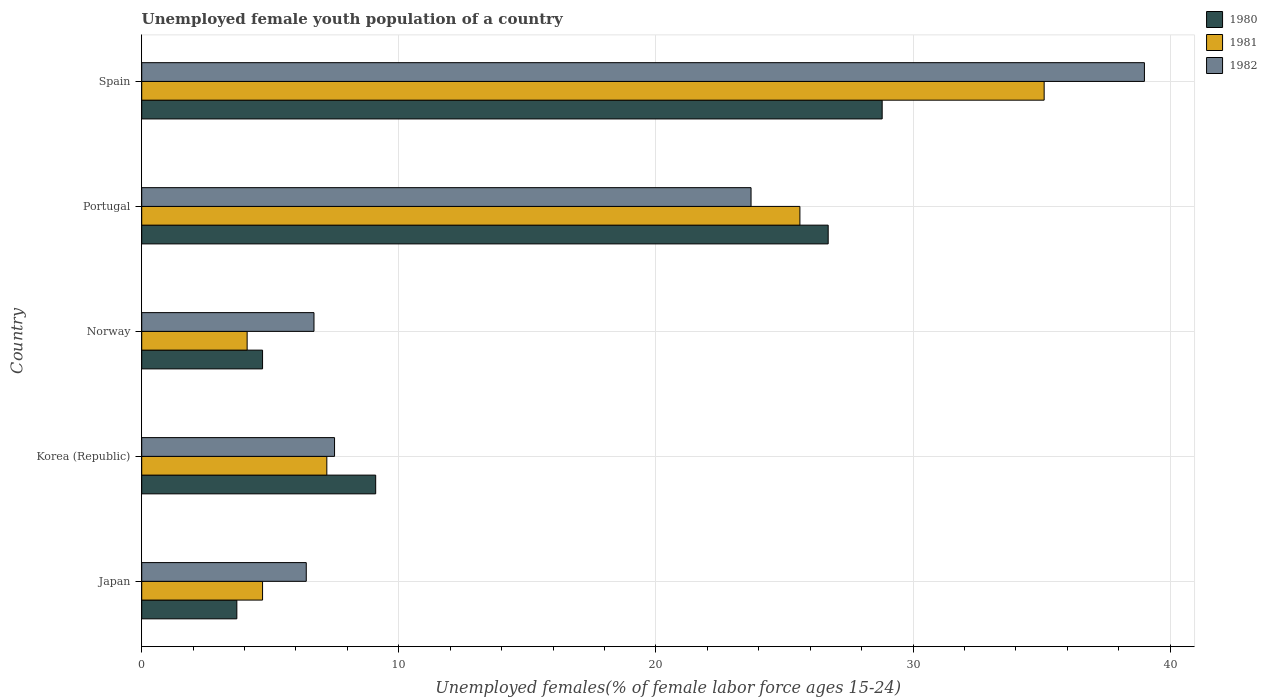How many different coloured bars are there?
Offer a terse response. 3. What is the percentage of unemployed female youth population in 1982 in Japan?
Provide a succinct answer. 6.4. Across all countries, what is the minimum percentage of unemployed female youth population in 1980?
Ensure brevity in your answer.  3.7. In which country was the percentage of unemployed female youth population in 1981 maximum?
Keep it short and to the point. Spain. In which country was the percentage of unemployed female youth population in 1981 minimum?
Offer a very short reply. Norway. What is the total percentage of unemployed female youth population in 1980 in the graph?
Offer a very short reply. 73. What is the difference between the percentage of unemployed female youth population in 1982 in Japan and that in Norway?
Offer a terse response. -0.3. What is the difference between the percentage of unemployed female youth population in 1980 in Korea (Republic) and the percentage of unemployed female youth population in 1982 in Portugal?
Ensure brevity in your answer.  -14.6. What is the average percentage of unemployed female youth population in 1980 per country?
Make the answer very short. 14.6. What is the difference between the percentage of unemployed female youth population in 1982 and percentage of unemployed female youth population in 1981 in Japan?
Provide a short and direct response. 1.7. What is the ratio of the percentage of unemployed female youth population in 1980 in Japan to that in Norway?
Your answer should be very brief. 0.79. Is the difference between the percentage of unemployed female youth population in 1982 in Norway and Portugal greater than the difference between the percentage of unemployed female youth population in 1981 in Norway and Portugal?
Your answer should be compact. Yes. What is the difference between the highest and the second highest percentage of unemployed female youth population in 1982?
Your answer should be very brief. 15.3. What is the difference between the highest and the lowest percentage of unemployed female youth population in 1982?
Your response must be concise. 32.6. What does the 2nd bar from the top in Japan represents?
Provide a succinct answer. 1981. Are all the bars in the graph horizontal?
Your response must be concise. Yes. What is the difference between two consecutive major ticks on the X-axis?
Offer a very short reply. 10. Are the values on the major ticks of X-axis written in scientific E-notation?
Provide a short and direct response. No. Where does the legend appear in the graph?
Provide a succinct answer. Top right. How are the legend labels stacked?
Provide a succinct answer. Vertical. What is the title of the graph?
Your answer should be very brief. Unemployed female youth population of a country. Does "2000" appear as one of the legend labels in the graph?
Provide a succinct answer. No. What is the label or title of the X-axis?
Make the answer very short. Unemployed females(% of female labor force ages 15-24). What is the label or title of the Y-axis?
Your answer should be compact. Country. What is the Unemployed females(% of female labor force ages 15-24) in 1980 in Japan?
Give a very brief answer. 3.7. What is the Unemployed females(% of female labor force ages 15-24) of 1981 in Japan?
Offer a terse response. 4.7. What is the Unemployed females(% of female labor force ages 15-24) of 1982 in Japan?
Offer a terse response. 6.4. What is the Unemployed females(% of female labor force ages 15-24) of 1980 in Korea (Republic)?
Give a very brief answer. 9.1. What is the Unemployed females(% of female labor force ages 15-24) in 1981 in Korea (Republic)?
Give a very brief answer. 7.2. What is the Unemployed females(% of female labor force ages 15-24) of 1980 in Norway?
Keep it short and to the point. 4.7. What is the Unemployed females(% of female labor force ages 15-24) of 1981 in Norway?
Ensure brevity in your answer.  4.1. What is the Unemployed females(% of female labor force ages 15-24) of 1982 in Norway?
Offer a very short reply. 6.7. What is the Unemployed females(% of female labor force ages 15-24) in 1980 in Portugal?
Ensure brevity in your answer.  26.7. What is the Unemployed females(% of female labor force ages 15-24) in 1981 in Portugal?
Give a very brief answer. 25.6. What is the Unemployed females(% of female labor force ages 15-24) of 1982 in Portugal?
Make the answer very short. 23.7. What is the Unemployed females(% of female labor force ages 15-24) in 1980 in Spain?
Keep it short and to the point. 28.8. What is the Unemployed females(% of female labor force ages 15-24) of 1981 in Spain?
Offer a terse response. 35.1. What is the Unemployed females(% of female labor force ages 15-24) of 1982 in Spain?
Provide a succinct answer. 39. Across all countries, what is the maximum Unemployed females(% of female labor force ages 15-24) of 1980?
Make the answer very short. 28.8. Across all countries, what is the maximum Unemployed females(% of female labor force ages 15-24) of 1981?
Offer a very short reply. 35.1. Across all countries, what is the maximum Unemployed females(% of female labor force ages 15-24) of 1982?
Ensure brevity in your answer.  39. Across all countries, what is the minimum Unemployed females(% of female labor force ages 15-24) in 1980?
Offer a very short reply. 3.7. Across all countries, what is the minimum Unemployed females(% of female labor force ages 15-24) in 1981?
Your answer should be compact. 4.1. Across all countries, what is the minimum Unemployed females(% of female labor force ages 15-24) in 1982?
Give a very brief answer. 6.4. What is the total Unemployed females(% of female labor force ages 15-24) in 1980 in the graph?
Your response must be concise. 73. What is the total Unemployed females(% of female labor force ages 15-24) of 1981 in the graph?
Give a very brief answer. 76.7. What is the total Unemployed females(% of female labor force ages 15-24) in 1982 in the graph?
Ensure brevity in your answer.  83.3. What is the difference between the Unemployed females(% of female labor force ages 15-24) in 1982 in Japan and that in Korea (Republic)?
Provide a short and direct response. -1.1. What is the difference between the Unemployed females(% of female labor force ages 15-24) in 1980 in Japan and that in Norway?
Provide a short and direct response. -1. What is the difference between the Unemployed females(% of female labor force ages 15-24) of 1980 in Japan and that in Portugal?
Your response must be concise. -23. What is the difference between the Unemployed females(% of female labor force ages 15-24) in 1981 in Japan and that in Portugal?
Your answer should be compact. -20.9. What is the difference between the Unemployed females(% of female labor force ages 15-24) in 1982 in Japan and that in Portugal?
Keep it short and to the point. -17.3. What is the difference between the Unemployed females(% of female labor force ages 15-24) of 1980 in Japan and that in Spain?
Keep it short and to the point. -25.1. What is the difference between the Unemployed females(% of female labor force ages 15-24) of 1981 in Japan and that in Spain?
Keep it short and to the point. -30.4. What is the difference between the Unemployed females(% of female labor force ages 15-24) of 1982 in Japan and that in Spain?
Provide a succinct answer. -32.6. What is the difference between the Unemployed females(% of female labor force ages 15-24) of 1982 in Korea (Republic) and that in Norway?
Offer a terse response. 0.8. What is the difference between the Unemployed females(% of female labor force ages 15-24) in 1980 in Korea (Republic) and that in Portugal?
Your response must be concise. -17.6. What is the difference between the Unemployed females(% of female labor force ages 15-24) in 1981 in Korea (Republic) and that in Portugal?
Ensure brevity in your answer.  -18.4. What is the difference between the Unemployed females(% of female labor force ages 15-24) in 1982 in Korea (Republic) and that in Portugal?
Provide a succinct answer. -16.2. What is the difference between the Unemployed females(% of female labor force ages 15-24) in 1980 in Korea (Republic) and that in Spain?
Offer a terse response. -19.7. What is the difference between the Unemployed females(% of female labor force ages 15-24) in 1981 in Korea (Republic) and that in Spain?
Offer a terse response. -27.9. What is the difference between the Unemployed females(% of female labor force ages 15-24) in 1982 in Korea (Republic) and that in Spain?
Offer a very short reply. -31.5. What is the difference between the Unemployed females(% of female labor force ages 15-24) in 1981 in Norway and that in Portugal?
Your response must be concise. -21.5. What is the difference between the Unemployed females(% of female labor force ages 15-24) of 1980 in Norway and that in Spain?
Make the answer very short. -24.1. What is the difference between the Unemployed females(% of female labor force ages 15-24) in 1981 in Norway and that in Spain?
Offer a terse response. -31. What is the difference between the Unemployed females(% of female labor force ages 15-24) of 1982 in Norway and that in Spain?
Offer a very short reply. -32.3. What is the difference between the Unemployed females(% of female labor force ages 15-24) of 1980 in Portugal and that in Spain?
Your answer should be very brief. -2.1. What is the difference between the Unemployed females(% of female labor force ages 15-24) in 1981 in Portugal and that in Spain?
Offer a terse response. -9.5. What is the difference between the Unemployed females(% of female labor force ages 15-24) of 1982 in Portugal and that in Spain?
Your answer should be compact. -15.3. What is the difference between the Unemployed females(% of female labor force ages 15-24) of 1980 in Japan and the Unemployed females(% of female labor force ages 15-24) of 1981 in Korea (Republic)?
Make the answer very short. -3.5. What is the difference between the Unemployed females(% of female labor force ages 15-24) in 1980 in Japan and the Unemployed females(% of female labor force ages 15-24) in 1982 in Korea (Republic)?
Keep it short and to the point. -3.8. What is the difference between the Unemployed females(% of female labor force ages 15-24) of 1980 in Japan and the Unemployed females(% of female labor force ages 15-24) of 1982 in Norway?
Your answer should be compact. -3. What is the difference between the Unemployed females(% of female labor force ages 15-24) in 1981 in Japan and the Unemployed females(% of female labor force ages 15-24) in 1982 in Norway?
Your answer should be compact. -2. What is the difference between the Unemployed females(% of female labor force ages 15-24) in 1980 in Japan and the Unemployed females(% of female labor force ages 15-24) in 1981 in Portugal?
Make the answer very short. -21.9. What is the difference between the Unemployed females(% of female labor force ages 15-24) in 1980 in Japan and the Unemployed females(% of female labor force ages 15-24) in 1982 in Portugal?
Give a very brief answer. -20. What is the difference between the Unemployed females(% of female labor force ages 15-24) of 1981 in Japan and the Unemployed females(% of female labor force ages 15-24) of 1982 in Portugal?
Your answer should be very brief. -19. What is the difference between the Unemployed females(% of female labor force ages 15-24) in 1980 in Japan and the Unemployed females(% of female labor force ages 15-24) in 1981 in Spain?
Offer a very short reply. -31.4. What is the difference between the Unemployed females(% of female labor force ages 15-24) in 1980 in Japan and the Unemployed females(% of female labor force ages 15-24) in 1982 in Spain?
Offer a very short reply. -35.3. What is the difference between the Unemployed females(% of female labor force ages 15-24) of 1981 in Japan and the Unemployed females(% of female labor force ages 15-24) of 1982 in Spain?
Your answer should be very brief. -34.3. What is the difference between the Unemployed females(% of female labor force ages 15-24) of 1980 in Korea (Republic) and the Unemployed females(% of female labor force ages 15-24) of 1981 in Norway?
Provide a succinct answer. 5. What is the difference between the Unemployed females(% of female labor force ages 15-24) in 1980 in Korea (Republic) and the Unemployed females(% of female labor force ages 15-24) in 1981 in Portugal?
Your response must be concise. -16.5. What is the difference between the Unemployed females(% of female labor force ages 15-24) in 1980 in Korea (Republic) and the Unemployed females(% of female labor force ages 15-24) in 1982 in Portugal?
Provide a short and direct response. -14.6. What is the difference between the Unemployed females(% of female labor force ages 15-24) of 1981 in Korea (Republic) and the Unemployed females(% of female labor force ages 15-24) of 1982 in Portugal?
Offer a terse response. -16.5. What is the difference between the Unemployed females(% of female labor force ages 15-24) in 1980 in Korea (Republic) and the Unemployed females(% of female labor force ages 15-24) in 1982 in Spain?
Provide a succinct answer. -29.9. What is the difference between the Unemployed females(% of female labor force ages 15-24) of 1981 in Korea (Republic) and the Unemployed females(% of female labor force ages 15-24) of 1982 in Spain?
Your answer should be compact. -31.8. What is the difference between the Unemployed females(% of female labor force ages 15-24) of 1980 in Norway and the Unemployed females(% of female labor force ages 15-24) of 1981 in Portugal?
Your response must be concise. -20.9. What is the difference between the Unemployed females(% of female labor force ages 15-24) of 1980 in Norway and the Unemployed females(% of female labor force ages 15-24) of 1982 in Portugal?
Keep it short and to the point. -19. What is the difference between the Unemployed females(% of female labor force ages 15-24) of 1981 in Norway and the Unemployed females(% of female labor force ages 15-24) of 1982 in Portugal?
Make the answer very short. -19.6. What is the difference between the Unemployed females(% of female labor force ages 15-24) in 1980 in Norway and the Unemployed females(% of female labor force ages 15-24) in 1981 in Spain?
Your answer should be very brief. -30.4. What is the difference between the Unemployed females(% of female labor force ages 15-24) of 1980 in Norway and the Unemployed females(% of female labor force ages 15-24) of 1982 in Spain?
Provide a short and direct response. -34.3. What is the difference between the Unemployed females(% of female labor force ages 15-24) of 1981 in Norway and the Unemployed females(% of female labor force ages 15-24) of 1982 in Spain?
Your answer should be very brief. -34.9. What is the difference between the Unemployed females(% of female labor force ages 15-24) in 1980 in Portugal and the Unemployed females(% of female labor force ages 15-24) in 1982 in Spain?
Offer a terse response. -12.3. What is the average Unemployed females(% of female labor force ages 15-24) of 1980 per country?
Your answer should be very brief. 14.6. What is the average Unemployed females(% of female labor force ages 15-24) in 1981 per country?
Ensure brevity in your answer.  15.34. What is the average Unemployed females(% of female labor force ages 15-24) in 1982 per country?
Keep it short and to the point. 16.66. What is the difference between the Unemployed females(% of female labor force ages 15-24) in 1980 and Unemployed females(% of female labor force ages 15-24) in 1982 in Japan?
Offer a terse response. -2.7. What is the difference between the Unemployed females(% of female labor force ages 15-24) in 1980 and Unemployed females(% of female labor force ages 15-24) in 1981 in Korea (Republic)?
Give a very brief answer. 1.9. What is the difference between the Unemployed females(% of female labor force ages 15-24) in 1981 and Unemployed females(% of female labor force ages 15-24) in 1982 in Korea (Republic)?
Ensure brevity in your answer.  -0.3. What is the difference between the Unemployed females(% of female labor force ages 15-24) in 1980 and Unemployed females(% of female labor force ages 15-24) in 1982 in Norway?
Keep it short and to the point. -2. What is the difference between the Unemployed females(% of female labor force ages 15-24) of 1981 and Unemployed females(% of female labor force ages 15-24) of 1982 in Spain?
Your response must be concise. -3.9. What is the ratio of the Unemployed females(% of female labor force ages 15-24) of 1980 in Japan to that in Korea (Republic)?
Provide a succinct answer. 0.41. What is the ratio of the Unemployed females(% of female labor force ages 15-24) in 1981 in Japan to that in Korea (Republic)?
Offer a very short reply. 0.65. What is the ratio of the Unemployed females(% of female labor force ages 15-24) of 1982 in Japan to that in Korea (Republic)?
Ensure brevity in your answer.  0.85. What is the ratio of the Unemployed females(% of female labor force ages 15-24) in 1980 in Japan to that in Norway?
Your answer should be compact. 0.79. What is the ratio of the Unemployed females(% of female labor force ages 15-24) of 1981 in Japan to that in Norway?
Your answer should be very brief. 1.15. What is the ratio of the Unemployed females(% of female labor force ages 15-24) in 1982 in Japan to that in Norway?
Ensure brevity in your answer.  0.96. What is the ratio of the Unemployed females(% of female labor force ages 15-24) of 1980 in Japan to that in Portugal?
Give a very brief answer. 0.14. What is the ratio of the Unemployed females(% of female labor force ages 15-24) of 1981 in Japan to that in Portugal?
Your answer should be very brief. 0.18. What is the ratio of the Unemployed females(% of female labor force ages 15-24) of 1982 in Japan to that in Portugal?
Provide a short and direct response. 0.27. What is the ratio of the Unemployed females(% of female labor force ages 15-24) in 1980 in Japan to that in Spain?
Provide a succinct answer. 0.13. What is the ratio of the Unemployed females(% of female labor force ages 15-24) of 1981 in Japan to that in Spain?
Provide a succinct answer. 0.13. What is the ratio of the Unemployed females(% of female labor force ages 15-24) of 1982 in Japan to that in Spain?
Provide a succinct answer. 0.16. What is the ratio of the Unemployed females(% of female labor force ages 15-24) of 1980 in Korea (Republic) to that in Norway?
Offer a very short reply. 1.94. What is the ratio of the Unemployed females(% of female labor force ages 15-24) in 1981 in Korea (Republic) to that in Norway?
Your answer should be very brief. 1.76. What is the ratio of the Unemployed females(% of female labor force ages 15-24) of 1982 in Korea (Republic) to that in Norway?
Make the answer very short. 1.12. What is the ratio of the Unemployed females(% of female labor force ages 15-24) of 1980 in Korea (Republic) to that in Portugal?
Provide a succinct answer. 0.34. What is the ratio of the Unemployed females(% of female labor force ages 15-24) of 1981 in Korea (Republic) to that in Portugal?
Your response must be concise. 0.28. What is the ratio of the Unemployed females(% of female labor force ages 15-24) of 1982 in Korea (Republic) to that in Portugal?
Keep it short and to the point. 0.32. What is the ratio of the Unemployed females(% of female labor force ages 15-24) in 1980 in Korea (Republic) to that in Spain?
Ensure brevity in your answer.  0.32. What is the ratio of the Unemployed females(% of female labor force ages 15-24) of 1981 in Korea (Republic) to that in Spain?
Make the answer very short. 0.21. What is the ratio of the Unemployed females(% of female labor force ages 15-24) of 1982 in Korea (Republic) to that in Spain?
Your response must be concise. 0.19. What is the ratio of the Unemployed females(% of female labor force ages 15-24) in 1980 in Norway to that in Portugal?
Offer a very short reply. 0.18. What is the ratio of the Unemployed females(% of female labor force ages 15-24) of 1981 in Norway to that in Portugal?
Your answer should be compact. 0.16. What is the ratio of the Unemployed females(% of female labor force ages 15-24) in 1982 in Norway to that in Portugal?
Ensure brevity in your answer.  0.28. What is the ratio of the Unemployed females(% of female labor force ages 15-24) of 1980 in Norway to that in Spain?
Your answer should be very brief. 0.16. What is the ratio of the Unemployed females(% of female labor force ages 15-24) in 1981 in Norway to that in Spain?
Offer a very short reply. 0.12. What is the ratio of the Unemployed females(% of female labor force ages 15-24) of 1982 in Norway to that in Spain?
Make the answer very short. 0.17. What is the ratio of the Unemployed females(% of female labor force ages 15-24) in 1980 in Portugal to that in Spain?
Ensure brevity in your answer.  0.93. What is the ratio of the Unemployed females(% of female labor force ages 15-24) of 1981 in Portugal to that in Spain?
Offer a terse response. 0.73. What is the ratio of the Unemployed females(% of female labor force ages 15-24) in 1982 in Portugal to that in Spain?
Your answer should be compact. 0.61. What is the difference between the highest and the second highest Unemployed females(% of female labor force ages 15-24) of 1980?
Offer a very short reply. 2.1. What is the difference between the highest and the second highest Unemployed females(% of female labor force ages 15-24) in 1981?
Provide a succinct answer. 9.5. What is the difference between the highest and the second highest Unemployed females(% of female labor force ages 15-24) in 1982?
Provide a short and direct response. 15.3. What is the difference between the highest and the lowest Unemployed females(% of female labor force ages 15-24) of 1980?
Provide a succinct answer. 25.1. What is the difference between the highest and the lowest Unemployed females(% of female labor force ages 15-24) in 1982?
Keep it short and to the point. 32.6. 